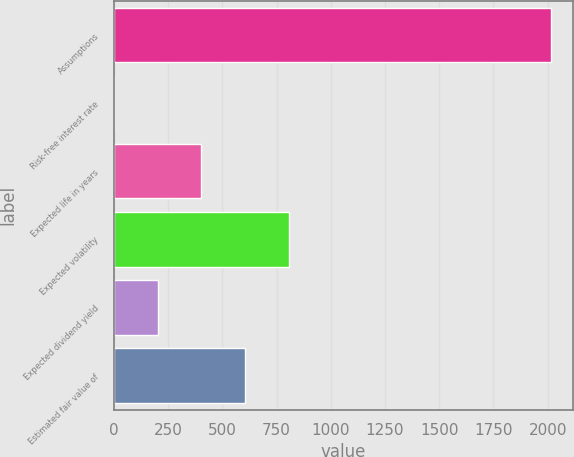Convert chart to OTSL. <chart><loc_0><loc_0><loc_500><loc_500><bar_chart><fcel>Assumptions<fcel>Risk-free interest rate<fcel>Expected life in years<fcel>Expected volatility<fcel>Expected dividend yield<fcel>Estimated fair value of<nl><fcel>2015<fcel>1.08<fcel>403.86<fcel>806.64<fcel>202.47<fcel>605.25<nl></chart> 